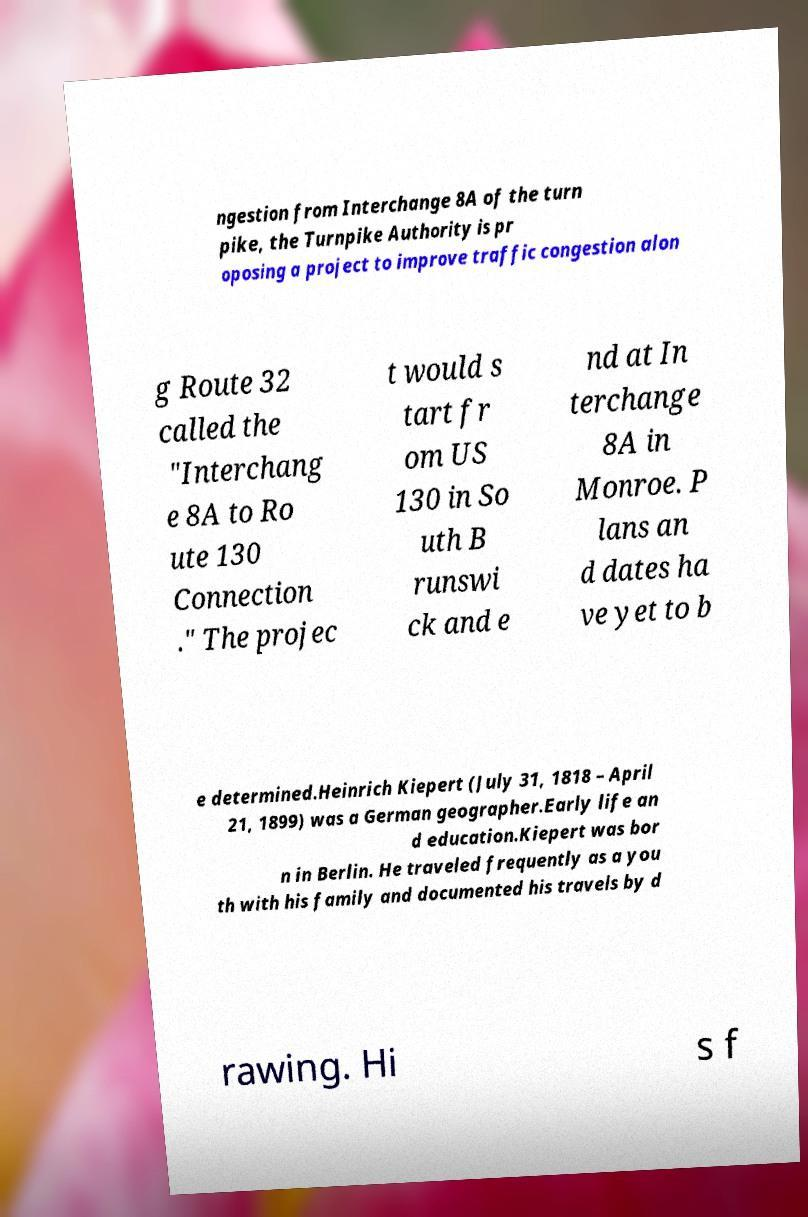Can you accurately transcribe the text from the provided image for me? ngestion from Interchange 8A of the turn pike, the Turnpike Authority is pr oposing a project to improve traffic congestion alon g Route 32 called the "Interchang e 8A to Ro ute 130 Connection ." The projec t would s tart fr om US 130 in So uth B runswi ck and e nd at In terchange 8A in Monroe. P lans an d dates ha ve yet to b e determined.Heinrich Kiepert (July 31, 1818 – April 21, 1899) was a German geographer.Early life an d education.Kiepert was bor n in Berlin. He traveled frequently as a you th with his family and documented his travels by d rawing. Hi s f 